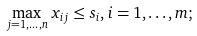Convert formula to latex. <formula><loc_0><loc_0><loc_500><loc_500>\max _ { j = 1 , \dots , n } x _ { i j } \leq s _ { i } , i = 1 , \dots , m ;</formula> 